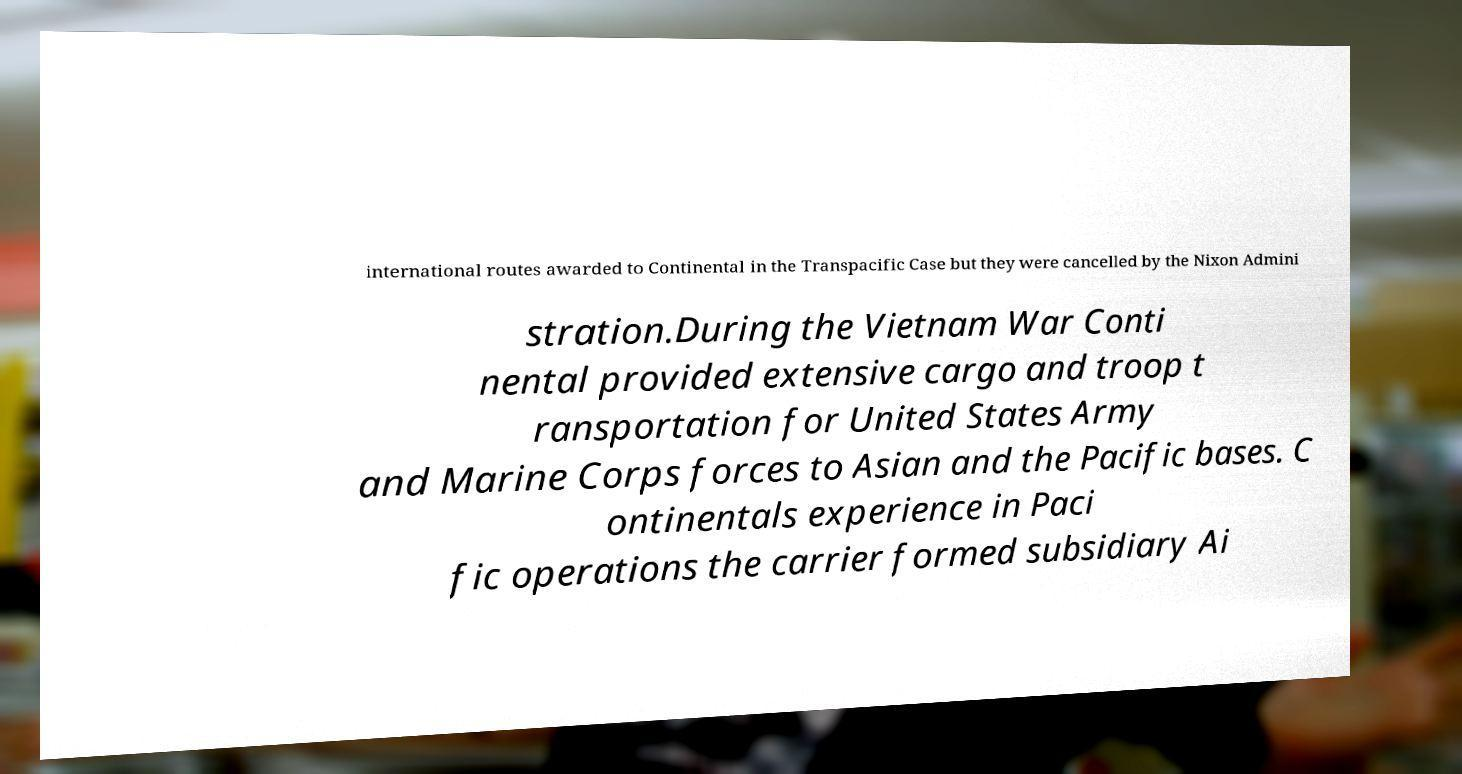Can you accurately transcribe the text from the provided image for me? international routes awarded to Continental in the Transpacific Case but they were cancelled by the Nixon Admini stration.During the Vietnam War Conti nental provided extensive cargo and troop t ransportation for United States Army and Marine Corps forces to Asian and the Pacific bases. C ontinentals experience in Paci fic operations the carrier formed subsidiary Ai 